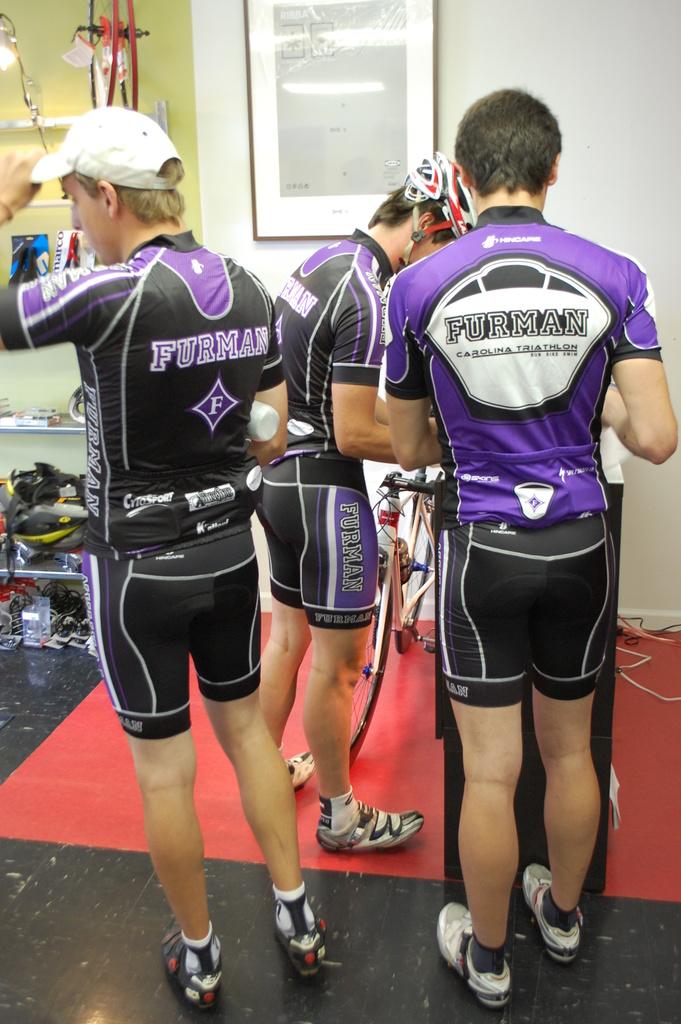What is the team name of what these men are part of?
Make the answer very short. Furman. What is on the man's shorts?
Provide a succinct answer. Unanswerable. 